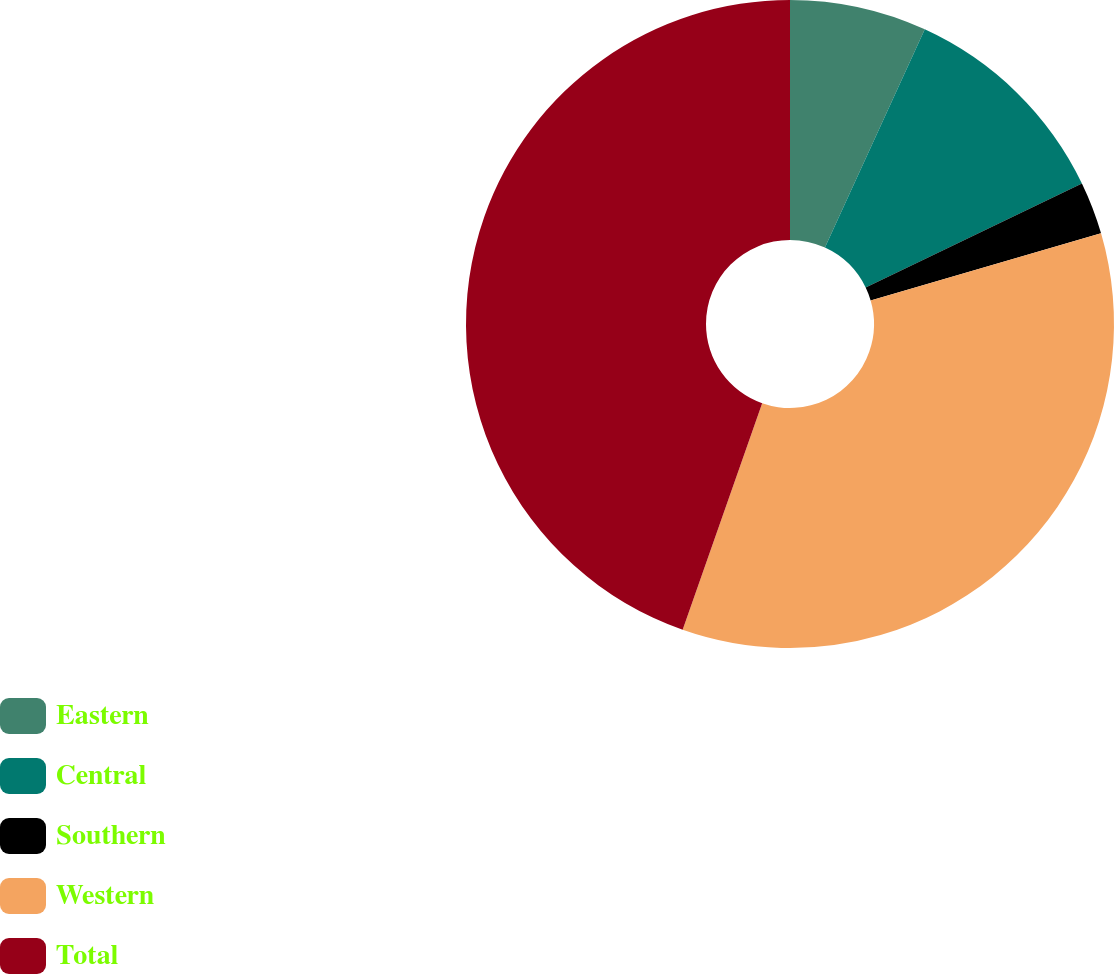Convert chart. <chart><loc_0><loc_0><loc_500><loc_500><pie_chart><fcel>Eastern<fcel>Central<fcel>Southern<fcel>Western<fcel>Total<nl><fcel>6.83%<fcel>11.03%<fcel>2.63%<fcel>34.89%<fcel>44.63%<nl></chart> 